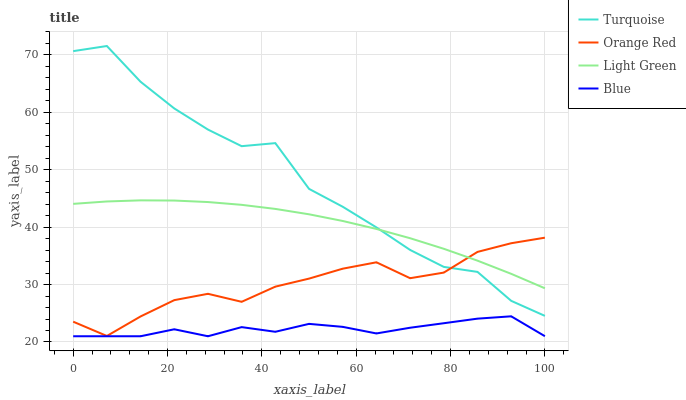Does Blue have the minimum area under the curve?
Answer yes or no. Yes. Does Turquoise have the maximum area under the curve?
Answer yes or no. Yes. Does Orange Red have the minimum area under the curve?
Answer yes or no. No. Does Orange Red have the maximum area under the curve?
Answer yes or no. No. Is Light Green the smoothest?
Answer yes or no. Yes. Is Turquoise the roughest?
Answer yes or no. Yes. Is Orange Red the smoothest?
Answer yes or no. No. Is Orange Red the roughest?
Answer yes or no. No. Does Blue have the lowest value?
Answer yes or no. Yes. Does Turquoise have the lowest value?
Answer yes or no. No. Does Turquoise have the highest value?
Answer yes or no. Yes. Does Orange Red have the highest value?
Answer yes or no. No. Is Blue less than Light Green?
Answer yes or no. Yes. Is Turquoise greater than Blue?
Answer yes or no. Yes. Does Orange Red intersect Turquoise?
Answer yes or no. Yes. Is Orange Red less than Turquoise?
Answer yes or no. No. Is Orange Red greater than Turquoise?
Answer yes or no. No. Does Blue intersect Light Green?
Answer yes or no. No. 